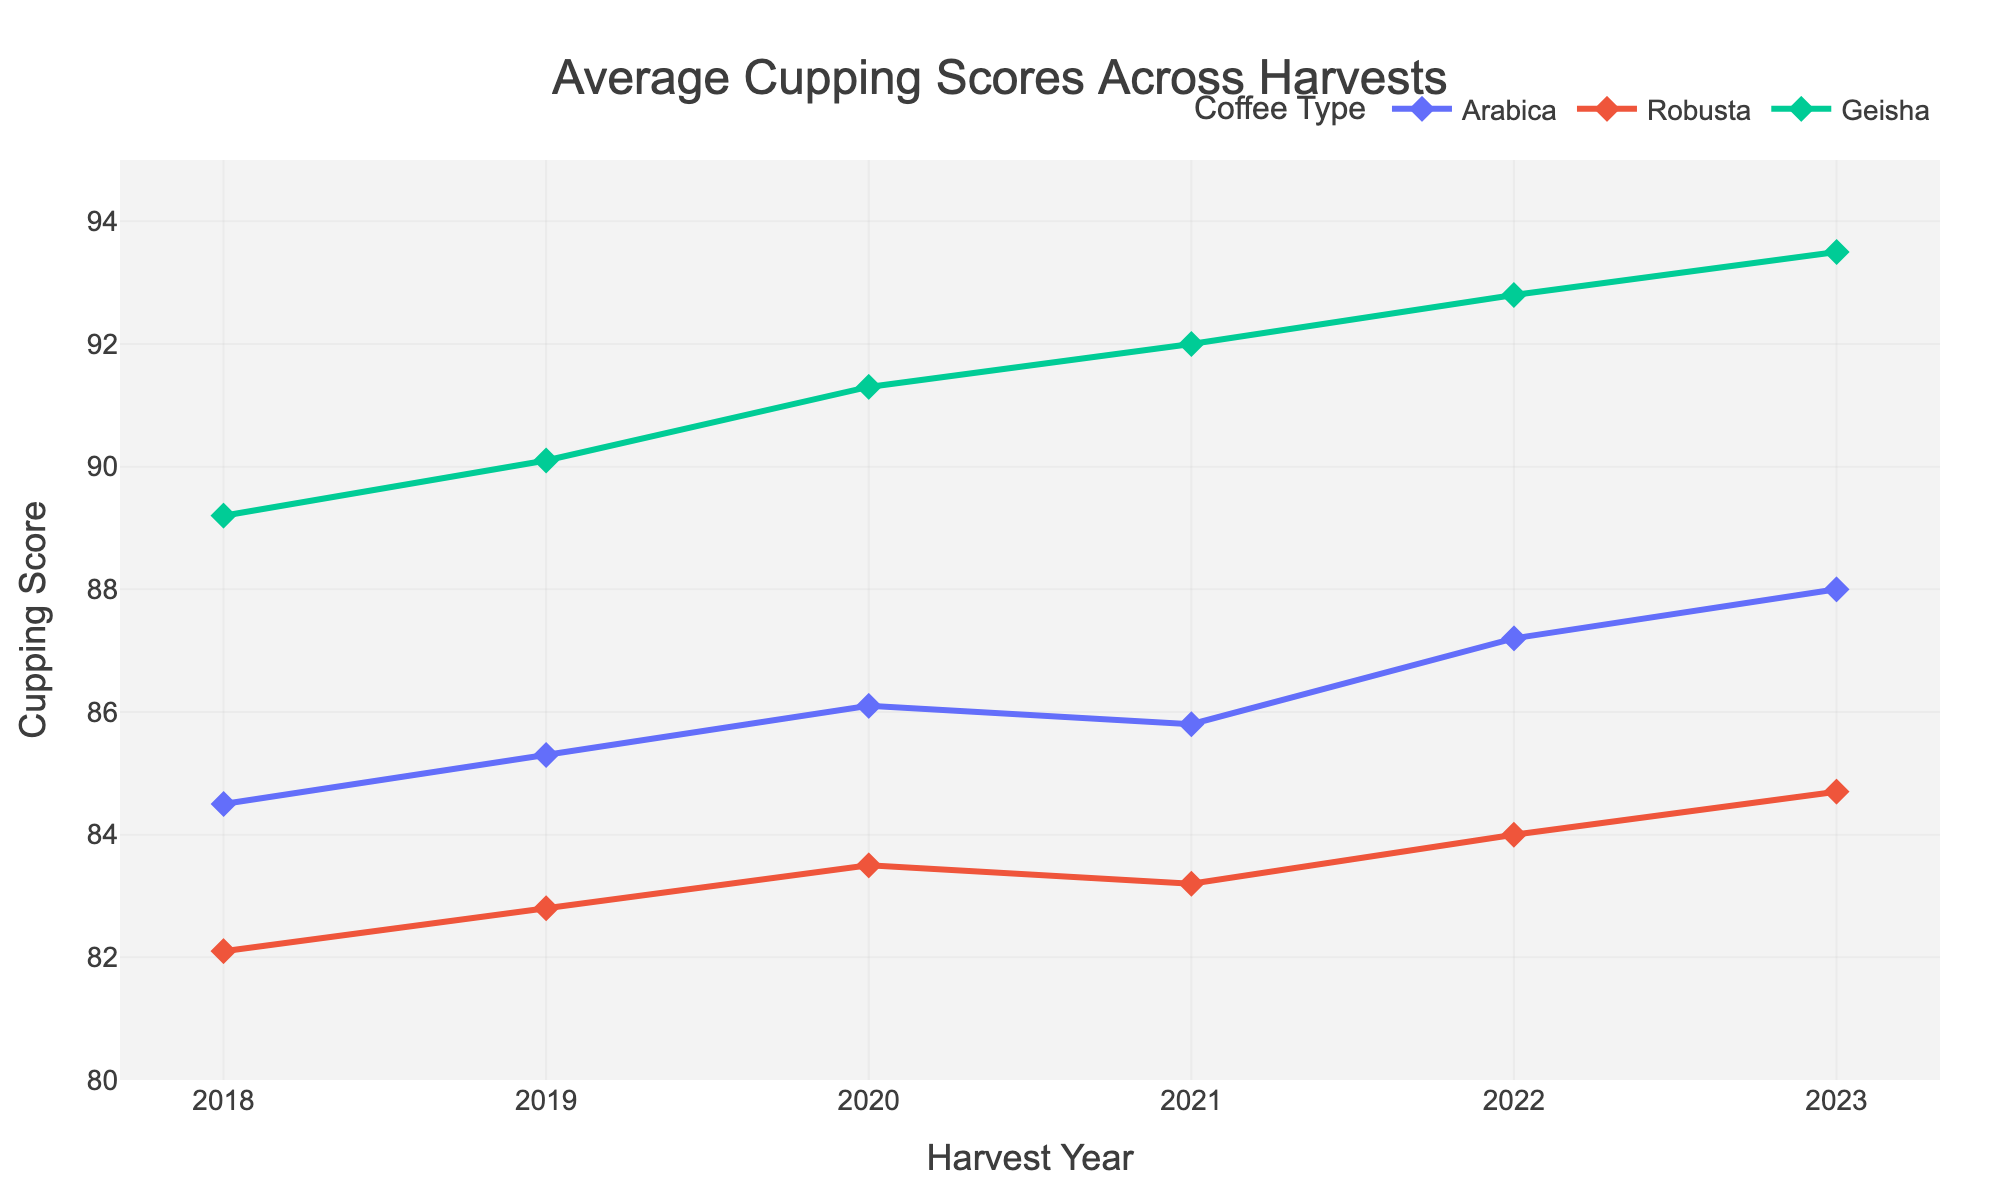How has the cupping score of Arabica changed from 2018 to 2023? To determine the change in the cupping score of Arabica from 2018 to 2023, we identify the scores in 2018 and 2023 from the plot. Arabica scored 84.5 in 2018 and 88.0 in 2023. The change is calculated as 88.0 - 84.5.
Answer: 3.5 Which coffee type had the highest average cupping score in 2021? To find the coffee type with the highest average cupping score in 2021, we compare the scores for Arabica, Robusta, and Geisha in that year. The plot shows scores of 85.8 for Arabica, 83.2 for Robusta, and 92.0 for Geisha. Geisha has the highest score.
Answer: Geisha What is the average cupping score of Robusta from 2018 to 2023? To calculate the average cupping score of Robusta over the years, sum the Robusta scores and divide by the number of years. The scores are 82.1, 82.8, 83.5, 83.2, 84.0, and 84.7. The sum is 500.3 and there are 6 years. The average is 500.3 / 6.
Answer: 83.4 Between which consecutive years did Geisha see the highest rise in cupping score? To find the highest rise for Geisha, calculate the differences between consecutive years' scores: (90.1-89.2) for 2018-2019, (91.3-90.1) for 2019-2020, (92.0-91.3) for 2020-2021, and (92.8-92.0) for 2021-2022, (93.5-92.8) for 2022-2023. The highest difference is 1.3, which occurred from 2018 to 2019.
Answer: 2018-2019 What trend can you observe for the Robusta score from 2018 to 2023? To infer the trend for Robusta scores over the years, observe the plot to note if the scores are consistently increasing, decreasing, or fluctuating. Robusta scores gradually increase from 82.1 in 2018 to 84.7 in 2023.
Answer: Increasing By how much did the average score of Geisha increase from 2018 to 2023? To find the increase, subtract the 2018 score from the 2023 score for Geisha. Geisha scored 89.2 in 2018 and 93.5 in 2023. The increase is 93.5 - 89.2.
Answer: 4.3 Which coffee type showed the least improvement in cupping scores from 2018 to 2023? To determine the least improvement, compare the overall increase in scores for Arabica, Robusta, and Geisha. Calculate the differences: (93.5-89.2) for Geisha, (88.0-84.5) for Arabica, and (84.7-82.1) for Robusta. The smallest increase is for Robusta (2.6).
Answer: Robusta 